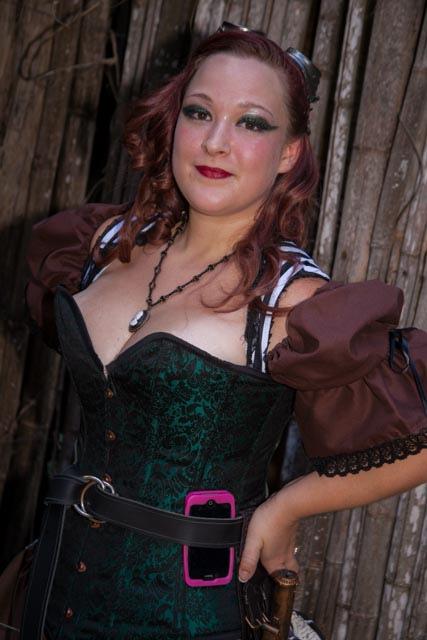Is she wearing a traditional dress?
Give a very brief answer. No. What color is the woman's necklace?
Quick response, please. Black. Is that a cell phone case with the belt?
Be succinct. Yes. 